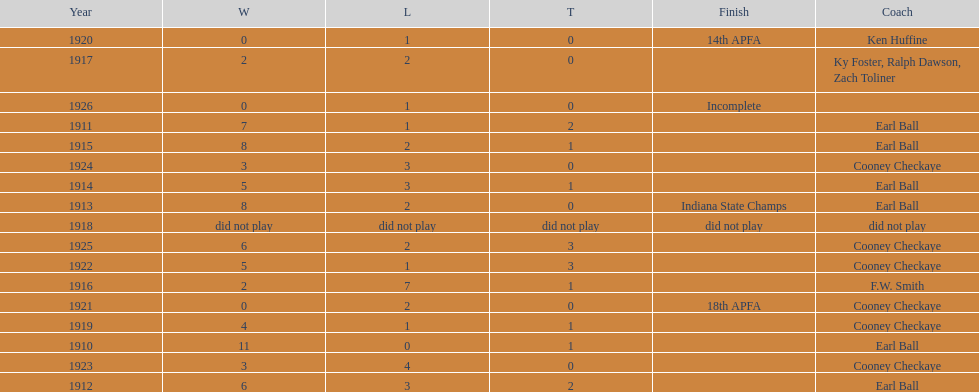The muncie flyers played from 1910 to 1925 in all but one of those years. which year did the flyers not play? 1918. 